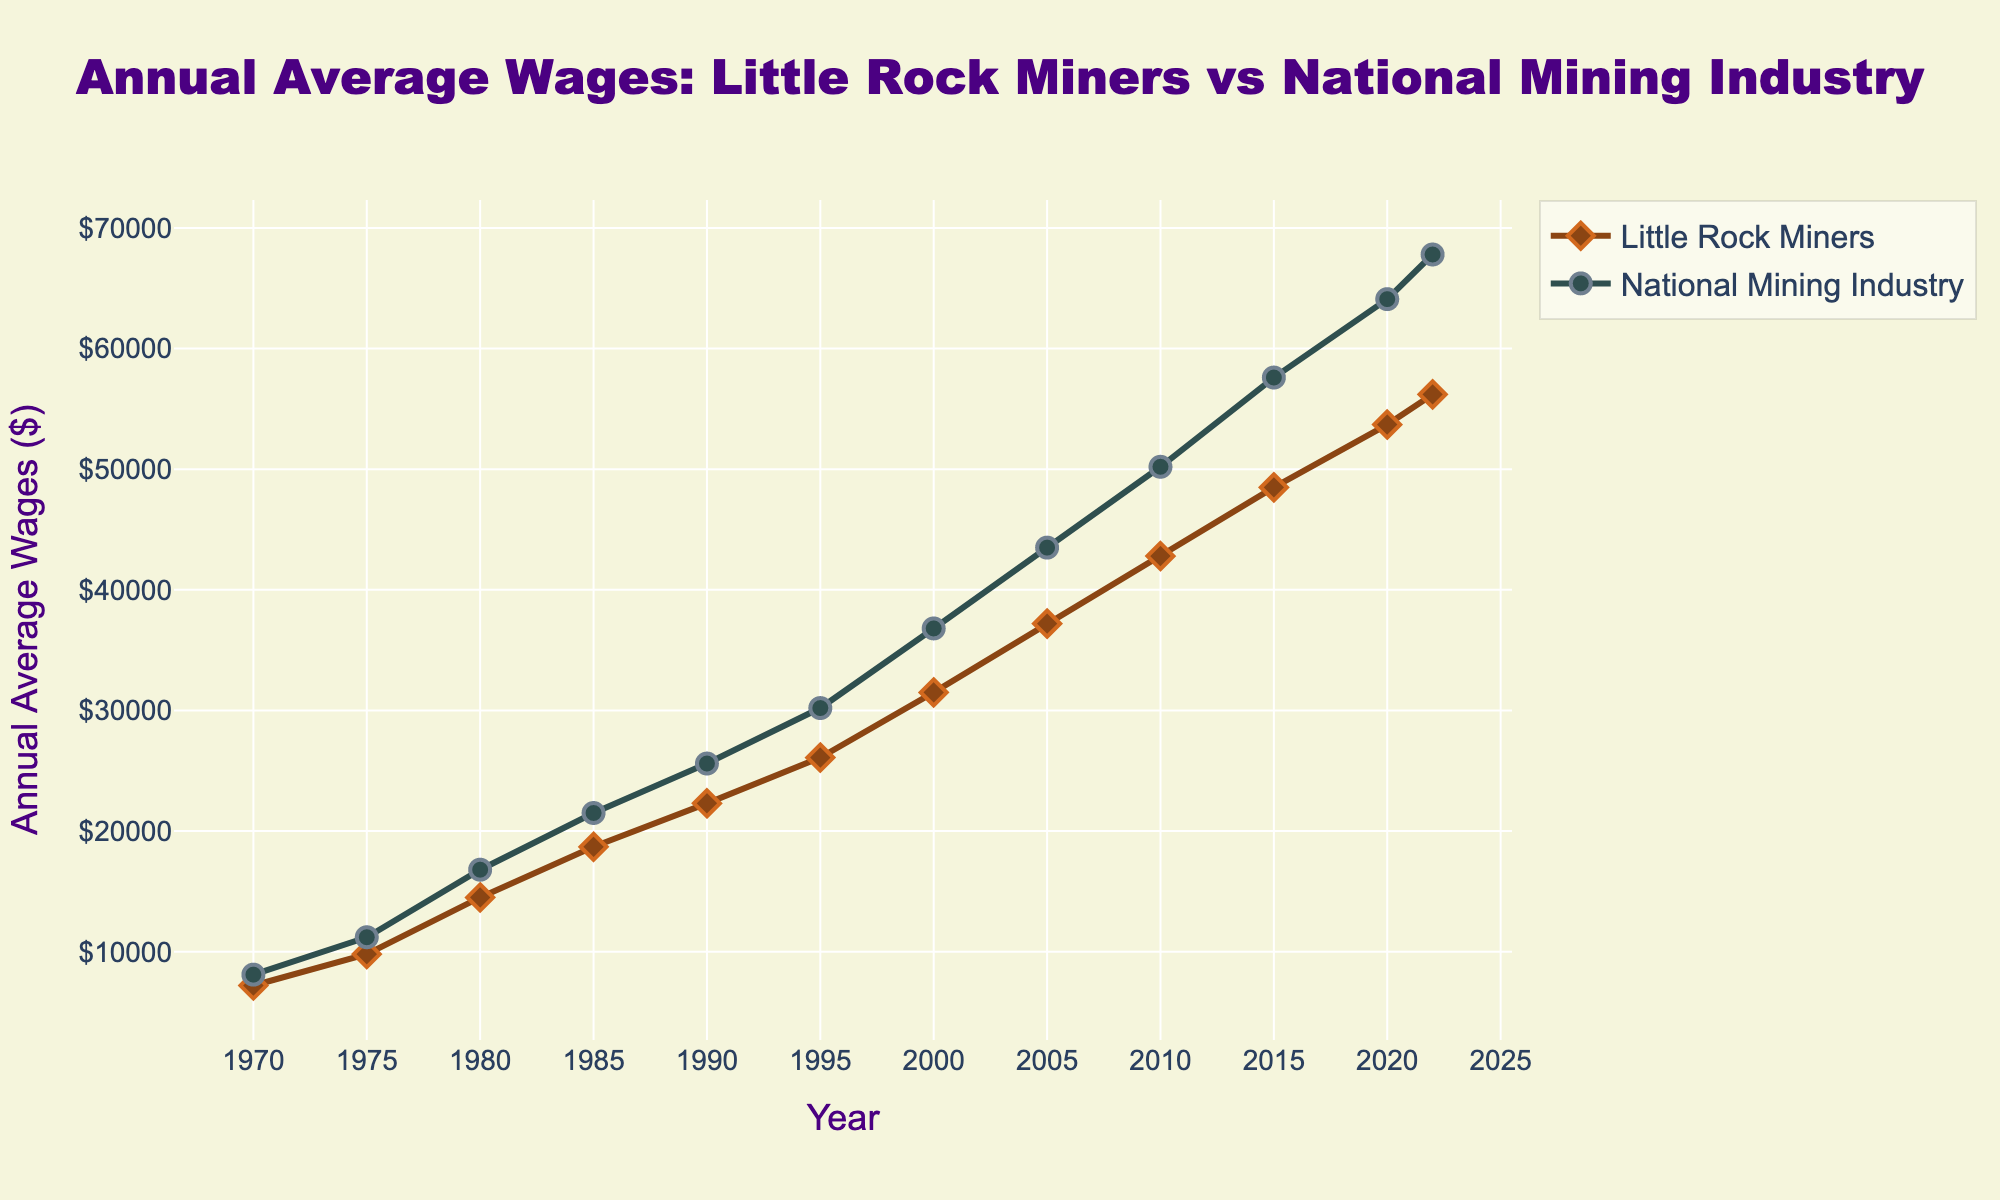What are the annual average wages for Little Rock miners in 1980 and the national mining industry in the same year? In the year 1980, look at the value on the "Little Rock Miners" line as well as the value on the "National Mining Industry" line. For Little Rock Miners, the wage is $14,500, and for the National Mining Industry, it is $16,800.
Answer: Little Rock Miners: $14,500; National Mining Industry: $16,800 Which year shows the highest wage gap between Little Rock miners and the national average? To find the year with the highest wage gap, look for the year where the distance between the "Little Rock Miners" line and the "National Mining Industry" line is the greatest. The largest gap appears in 2020, where the national average is $64,100 and Little Rock miners earn $53,700, a difference of $10,400.
Answer: 2020 Has the wage for Little Rock miners ever been equal to or greater than the national average? By examining the entire range of years, you can see if the "Little Rock Miners" line ever meets or surpasses the "National Mining Industry" line. It does not—Little Rock miners' wages have consistently been less than the national average.
Answer: No How much did the annual average wage for Little Rock miners increase from 1970 to 2000? To compute the increase, subtract the 1970 wage from the 2000 wage for Little Rock miners. The calculation is $31,500 (2000) - $7,200 (1970) = $24,300 increase.
Answer: $24,300 Which year experienced the smallest percentage increase in wages for Little Rock miners compared to the previous year? Calculate the percentage increase between consecutive years and find the smallest. The smallest percentage increase between consecutive datapoints occurs between 2020 and 2022. For 2020-2022: ($56,200 - $53,700) / $53,700 * 100 ≈ 4.65%.
Answer: 2020 to 2022 In which decade did Little Rock miners see the highest average annual wage growth? To determine this, calculate the average annual wage growth for each decade by finding the wage increase within that decade and then dividing by 10. The decade with the highest average annual wage growth for Little Rock miners is 1970-1980: ($14,500 - $7,200) / 10 = $ 730/year.
Answer: 1970-1980 How does the overall trend for Little Rock miners' wages compare to that of the national mining industry? Both lines show a steady increase over time, indicating that wages have been rising for both groups. The national mining industry tends to have higher wages, but the trends are similar in pattern.
Answer: Similar upward trend What is the percentage difference in wages between Little Rock miners and the national average in 2022? Calculate the percentage difference by using the formula [(National - Little Rock) / National] * 100. For 2022, the calculation is ($67,800 - $56,200) / $67,800 * 100 ≈ 17.09%.
Answer: 17.09% When did the wages for Little Rock miners first exceed $20,000? Locate the point on the "Little Rock Miners" line where it first rises above $20,000. This occurs around the year 1985.
Answer: 1985 